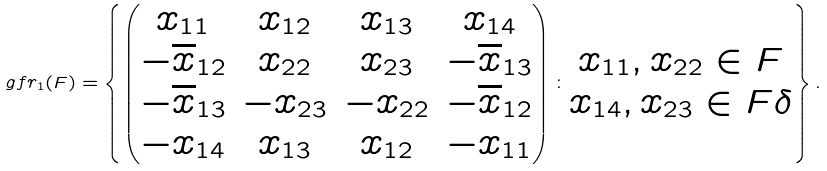Convert formula to latex. <formula><loc_0><loc_0><loc_500><loc_500>\ g f r _ { 1 } ( F ) = \left \{ \begin{pmatrix} x _ { 1 1 } & x _ { 1 2 } & x _ { 1 3 } & x _ { 1 4 } \\ - \overline { x } _ { 1 2 } & x _ { 2 2 } & x _ { 2 3 } & - \overline { x } _ { 1 3 } \\ - \overline { x } _ { 1 3 } & - x _ { 2 3 } & - x _ { 2 2 } & - \overline { x } _ { 1 2 } \\ - x _ { 1 4 } & x _ { 1 3 } & x _ { 1 2 } & - x _ { 1 1 } \end{pmatrix} \colon \begin{matrix} x _ { 1 1 } , x _ { 2 2 } \in F \\ x _ { 1 4 } , x _ { 2 3 } \in F \delta \end{matrix} \right \} .</formula> 